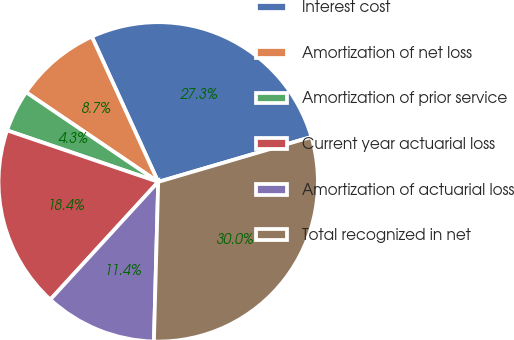Convert chart to OTSL. <chart><loc_0><loc_0><loc_500><loc_500><pie_chart><fcel>Interest cost<fcel>Amortization of net loss<fcel>Amortization of prior service<fcel>Current year actuarial loss<fcel>Amortization of actuarial loss<fcel>Total recognized in net<nl><fcel>27.28%<fcel>8.69%<fcel>4.26%<fcel>18.42%<fcel>11.38%<fcel>29.97%<nl></chart> 